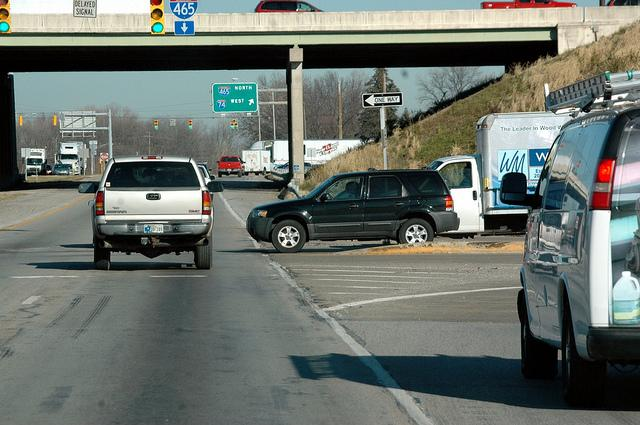How many traffic lights are hanging in the highway ahead facing toward the silver pickup truck?

Choices:
A) seven
B) four
C) five
D) six five 